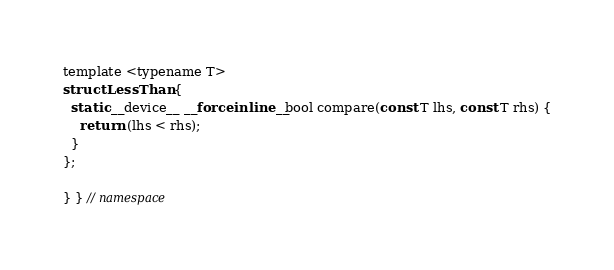<code> <loc_0><loc_0><loc_500><loc_500><_Cuda_>template <typename T>
struct LessThan {
  static __device__ __forceinline__ bool compare(const T lhs, const T rhs) {
    return (lhs < rhs);
  }
};

} } // namespace
</code> 